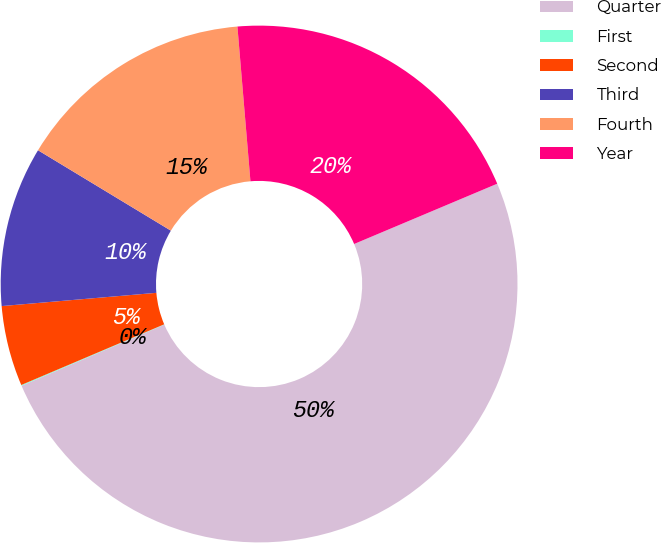<chart> <loc_0><loc_0><loc_500><loc_500><pie_chart><fcel>Quarter<fcel>First<fcel>Second<fcel>Third<fcel>Fourth<fcel>Year<nl><fcel>49.9%<fcel>0.05%<fcel>5.03%<fcel>10.02%<fcel>15.0%<fcel>19.99%<nl></chart> 